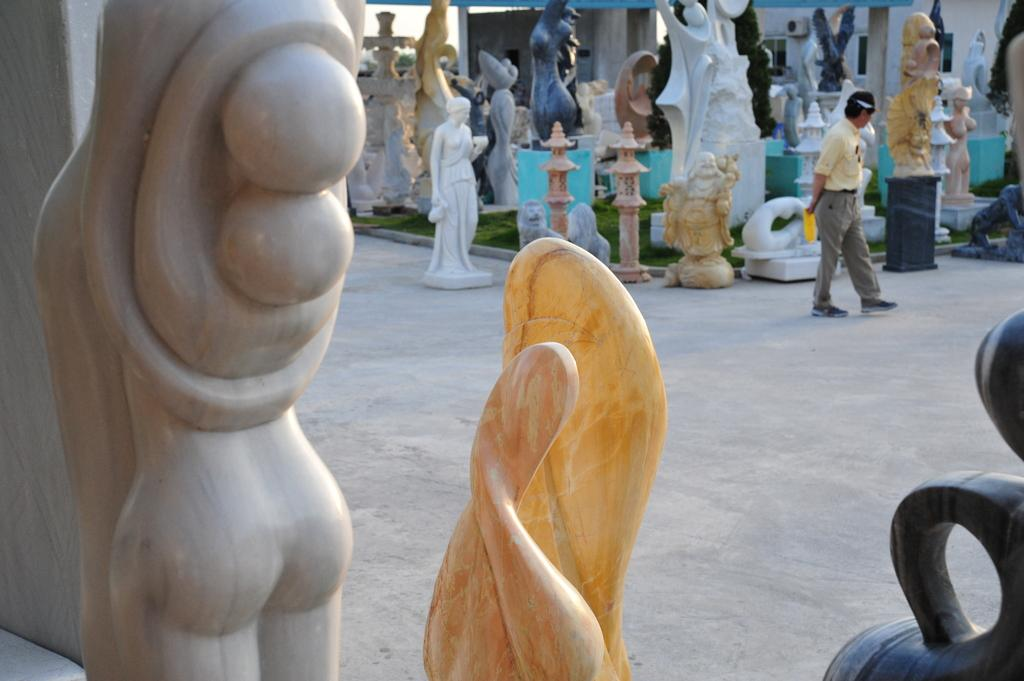What type of objects can be seen in the image? There are statues and sculptures in the image. How do the statues and sculptures differ from each other? The statues and sculptures have different shapes and colors. Can you describe the man's position in the image? The man is standing at the right side of the image. What type of poison is being used to maintain the garden in the image? There is no garden present in the image, and therefore no poison for maintaining it. 